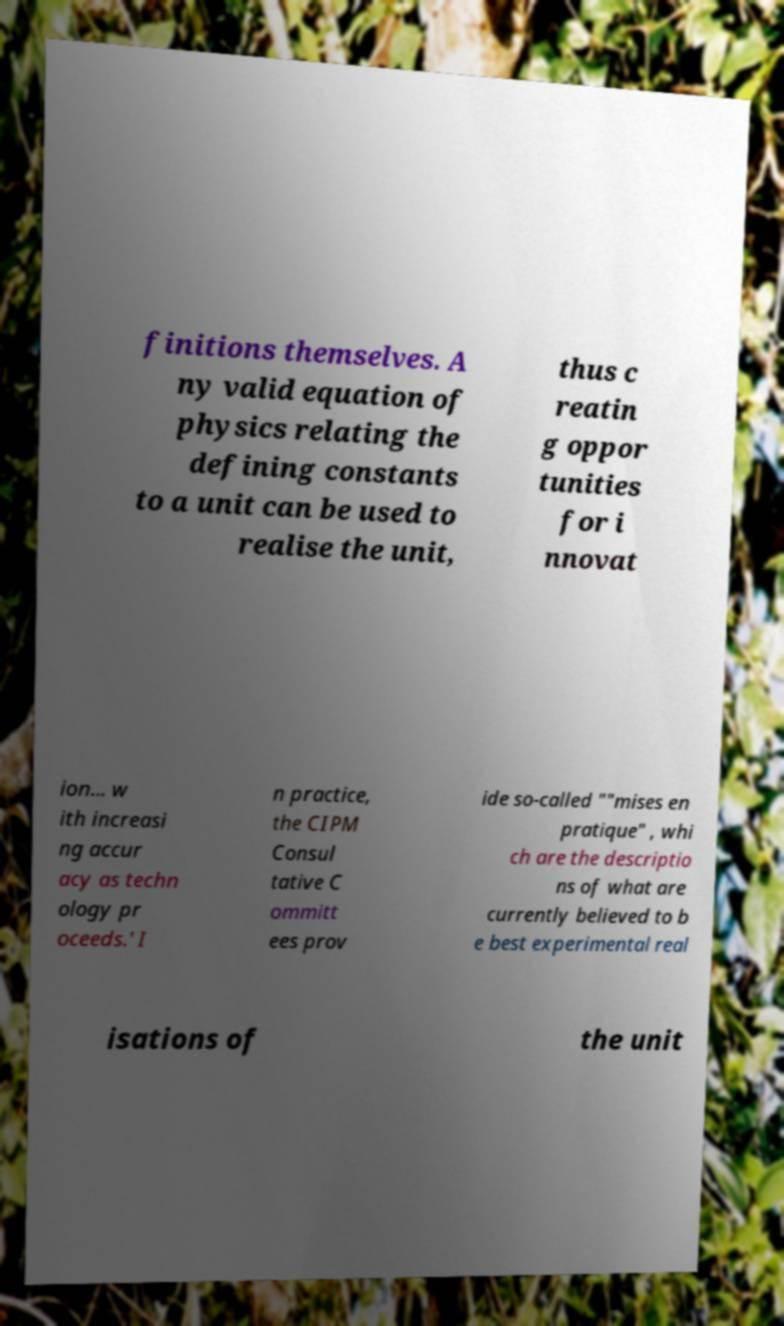What messages or text are displayed in this image? I need them in a readable, typed format. finitions themselves. A ny valid equation of physics relating the defining constants to a unit can be used to realise the unit, thus c reatin g oppor tunities for i nnovat ion... w ith increasi ng accur acy as techn ology pr oceeds.' I n practice, the CIPM Consul tative C ommitt ees prov ide so-called ""mises en pratique" , whi ch are the descriptio ns of what are currently believed to b e best experimental real isations of the unit 